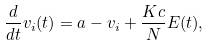<formula> <loc_0><loc_0><loc_500><loc_500>\frac { d } { d t } v _ { i } ( t ) = a - v _ { i } + \frac { K c } { N } E ( t ) ,</formula> 